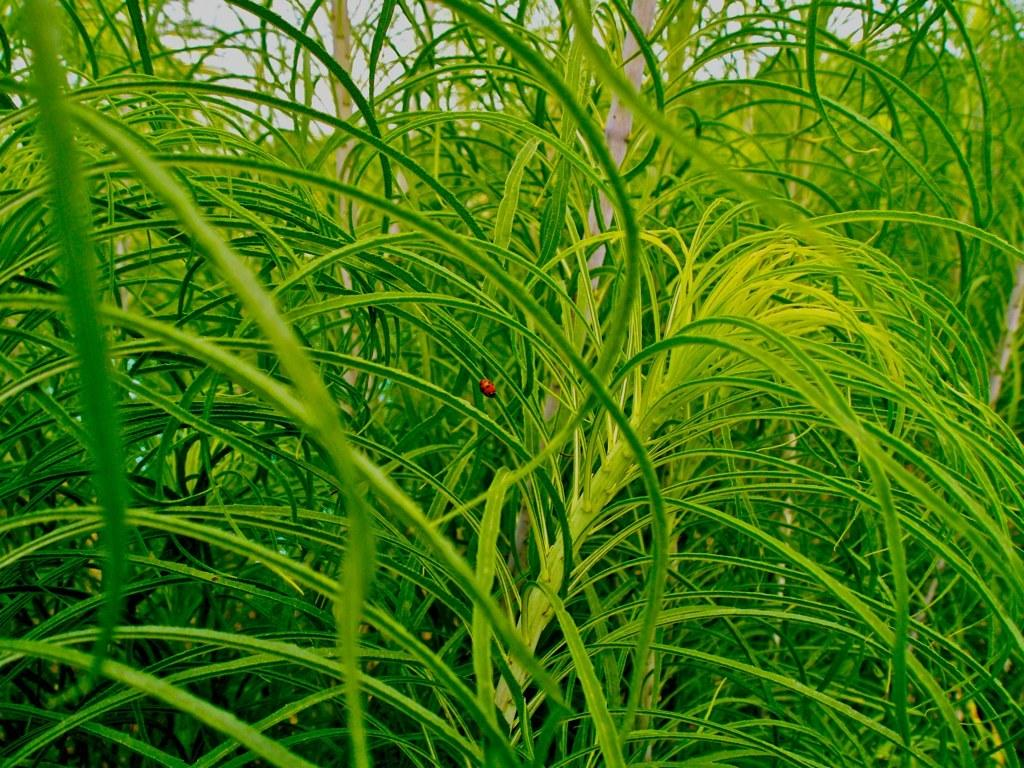What type of living organism can be seen on the plants in the image? There is an insect on the plants in the image. Where is the insect located in the image? The insect is in the center of the image. What can be seen in the background of the image? There is a sky visible in the background of the image. What type of music can be heard coming from the insect in the image? There is no indication in the image that the insect is making any sounds, so it's not possible to determine what, if any, music might be heard. 